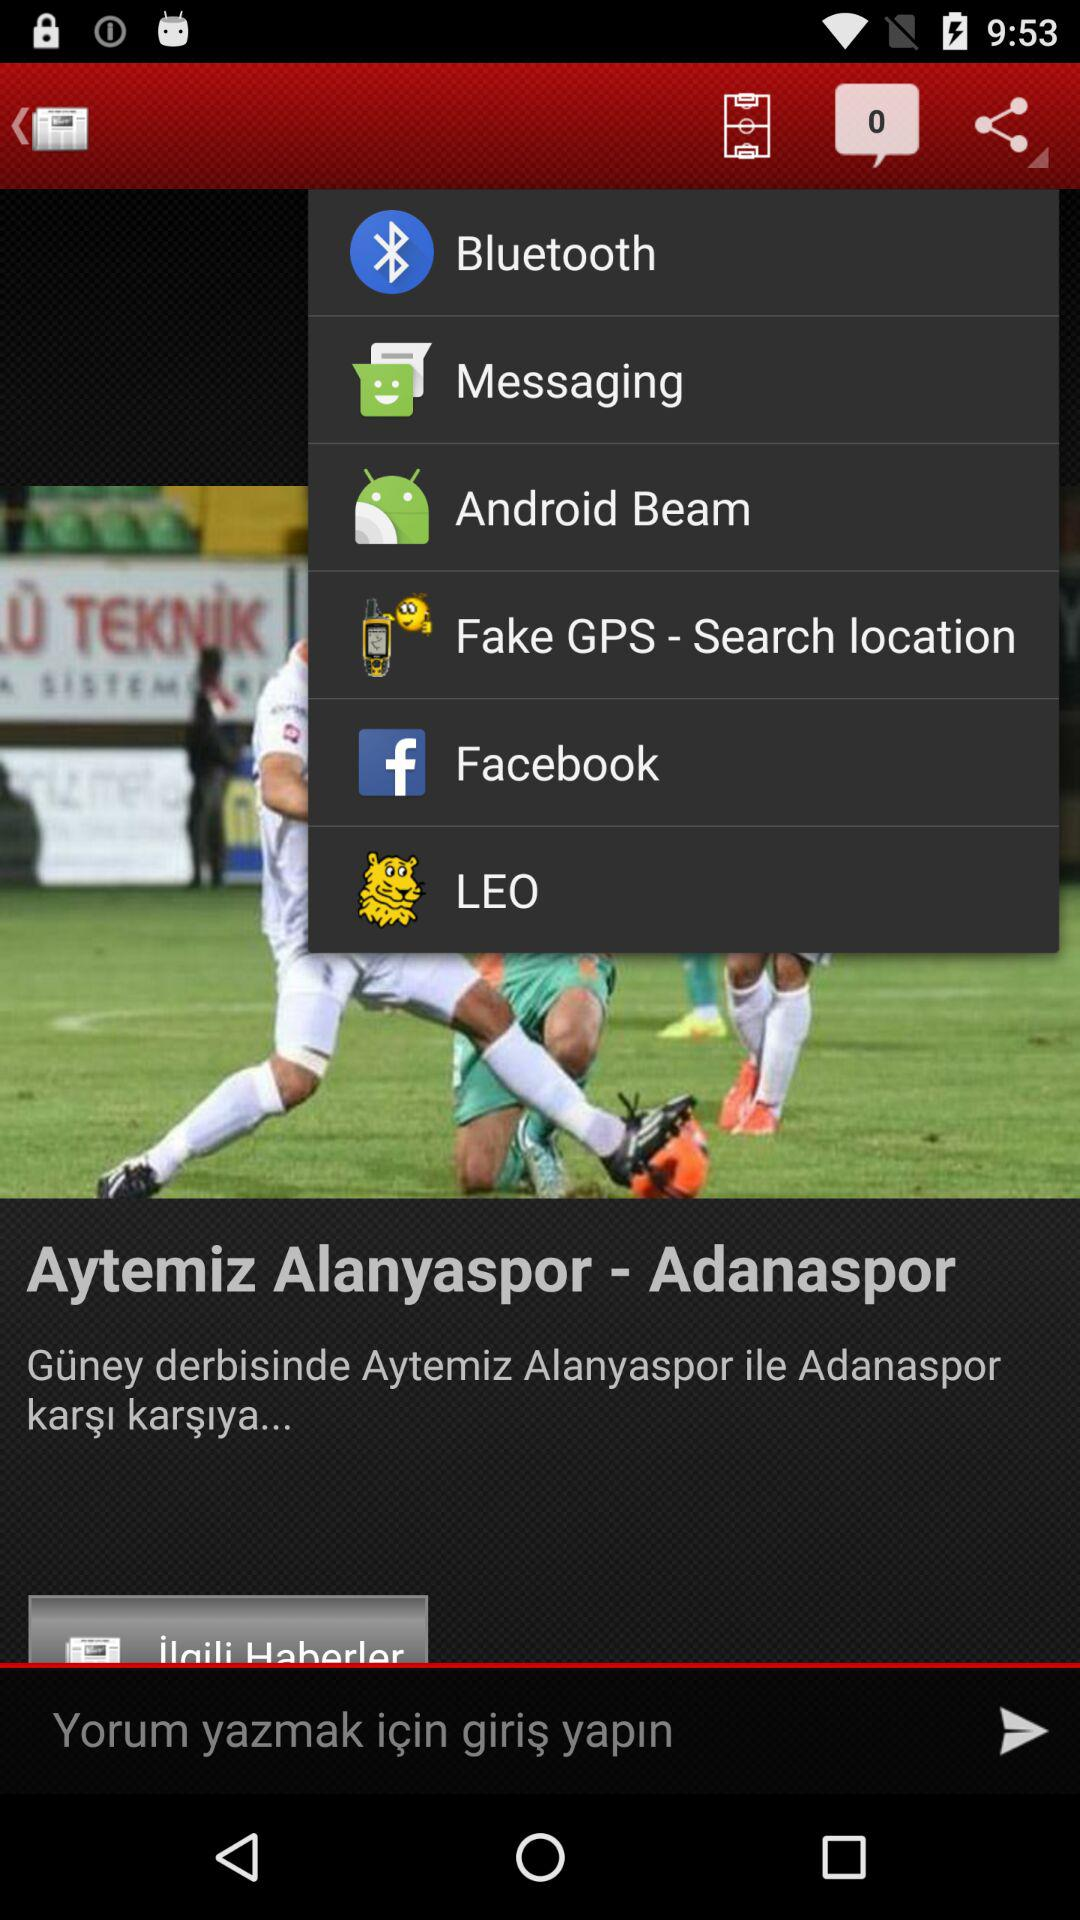Through which app can you share? You can share through "Bluetooth", "Messaging", "Android Beam", "Fake GPS - Search location", "Facebook" and "LEO". 